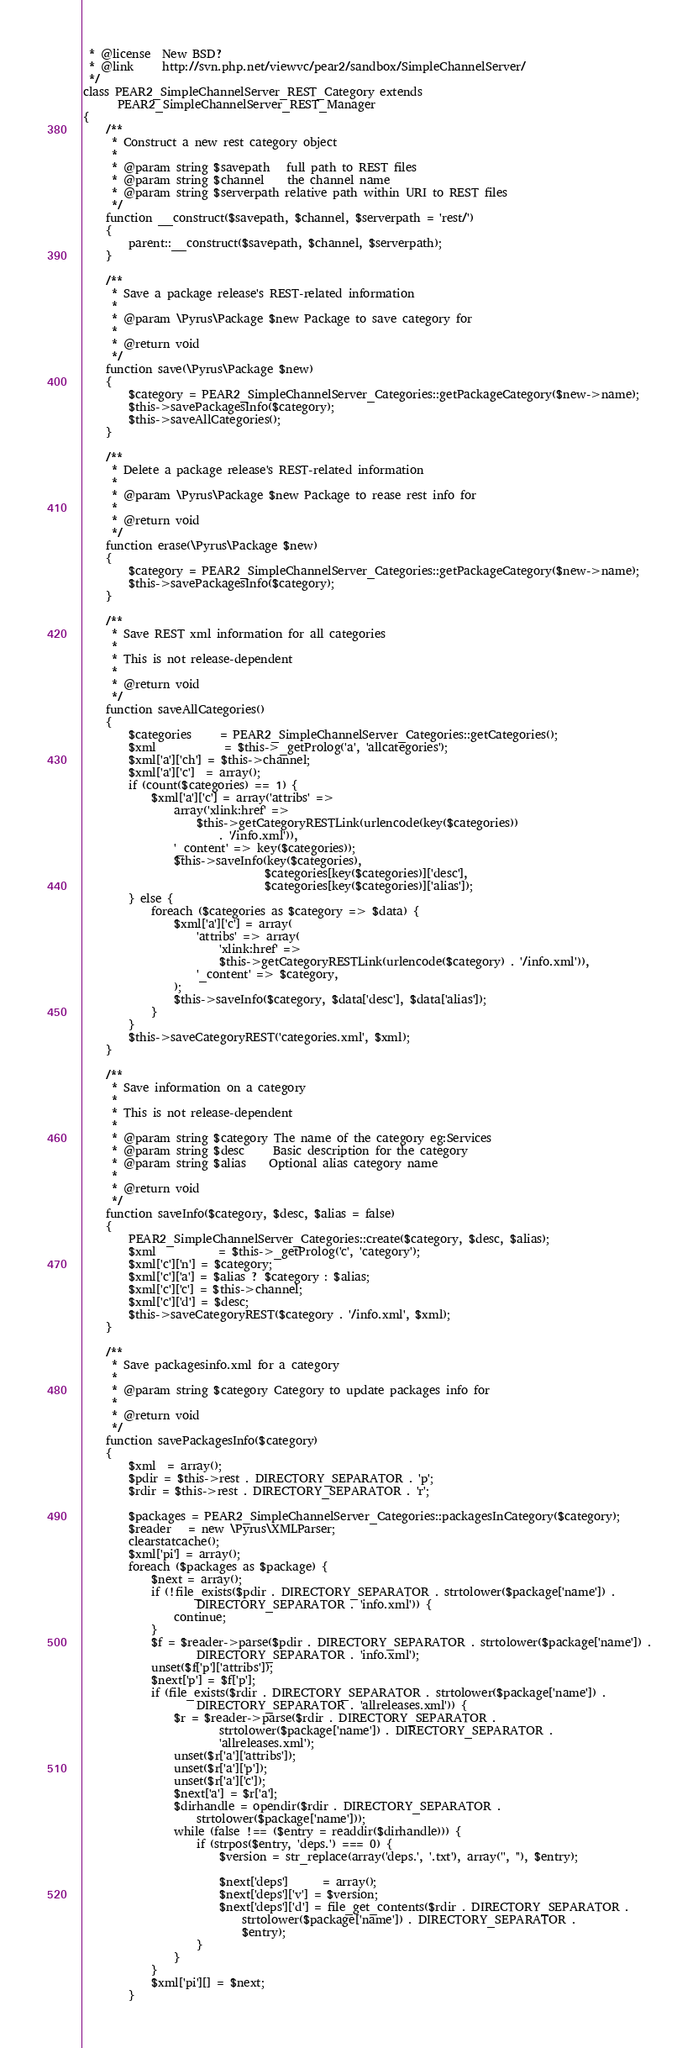<code> <loc_0><loc_0><loc_500><loc_500><_PHP_> * @license  New BSD?
 * @link     http://svn.php.net/viewvc/pear2/sandbox/SimpleChannelServer/
 */
class PEAR2_SimpleChannelServer_REST_Category extends
      PEAR2_SimpleChannelServer_REST_Manager
{
    /**
     * Construct a new rest category object
     * 
     * @param string $savepath   full path to REST files
     * @param string $channel    the channel name
     * @param string $serverpath relative path within URI to REST files
     */
    function __construct($savepath, $channel, $serverpath = 'rest/')
    {
        parent::__construct($savepath, $channel, $serverpath);
    }

    /**
     * Save a package release's REST-related information
     *
     * @param \Pyrus\Package $new Package to save category for
     * 
     * @return void
     */
    function save(\Pyrus\Package $new)
    {
        $category = PEAR2_SimpleChannelServer_Categories::getPackageCategory($new->name);
        $this->savePackagesInfo($category);
        $this->saveAllCategories();
    }

    /**
     * Delete a package release's REST-related information
     *
     * @param \Pyrus\Package $new Package to rease rest info for
     * 
     * @return void
     */
    function erase(\Pyrus\Package $new)
    {
        $category = PEAR2_SimpleChannelServer_Categories::getPackageCategory($new->name);
        $this->savePackagesInfo($category);
    }

    /**
     * Save REST xml information for all categories
     * 
     * This is not release-dependent
     * 
     * @return void
     */
    function saveAllCategories()
    {
        $categories     = PEAR2_SimpleChannelServer_Categories::getCategories();
        $xml            = $this->_getProlog('a', 'allcategories');
        $xml['a']['ch'] = $this->channel;
        $xml['a']['c']  = array();
        if (count($categories) == 1) {
            $xml['a']['c'] = array('attribs' =>
                array('xlink:href' =>
                    $this->getCategoryRESTLink(urlencode(key($categories))
                        . '/info.xml')),
                '_content' => key($categories));
                $this->saveInfo(key($categories),
                                $categories[key($categories)]['desc'],
                                $categories[key($categories)]['alias']);
        } else {
            foreach ($categories as $category => $data) {
                $xml['a']['c'] = array(
                    'attribs' => array(
                        'xlink:href' =>
                        $this->getCategoryRESTLink(urlencode($category) . '/info.xml')),
                    '_content' => $category,
                );
                $this->saveInfo($category, $data['desc'], $data['alias']);
            }
        }
        $this->saveCategoryREST('categories.xml', $xml);
    }

    /**
     * Save information on a category
     * 
     * This is not release-dependent
     *
     * @param string $category The name of the category eg:Services
     * @param string $desc     Basic description for the category
     * @param string $alias    Optional alias category name
     * 
     * @return void
     */
    function saveInfo($category, $desc, $alias = false)
    {
        PEAR2_SimpleChannelServer_Categories::create($category, $desc, $alias);
        $xml           = $this->_getProlog('c', 'category');
        $xml['c']['n'] = $category;
        $xml['c']['a'] = $alias ? $category : $alias;
        $xml['c']['c'] = $this->channel;
        $xml['c']['d'] = $desc;
        $this->saveCategoryREST($category . '/info.xml', $xml);
    }

    /**
     * Save packagesinfo.xml for a category
     *
     * @param string $category Category to update packages info for
     * 
     * @return void
     */
    function savePackagesInfo($category)
    {
        $xml  = array();
        $pdir = $this->rest . DIRECTORY_SEPARATOR . 'p';
        $rdir = $this->rest . DIRECTORY_SEPARATOR . 'r';

        $packages = PEAR2_SimpleChannelServer_Categories::packagesInCategory($category);
        $reader   = new \Pyrus\XMLParser;
        clearstatcache();
        $xml['pi'] = array();
        foreach ($packages as $package) {
            $next = array();
            if (!file_exists($pdir . DIRECTORY_SEPARATOR . strtolower($package['name']) .
                    DIRECTORY_SEPARATOR . 'info.xml')) {
                continue;
            }
            $f = $reader->parse($pdir . DIRECTORY_SEPARATOR . strtolower($package['name']) .
                    DIRECTORY_SEPARATOR . 'info.xml');
            unset($f['p']['attribs']);
            $next['p'] = $f['p'];
            if (file_exists($rdir . DIRECTORY_SEPARATOR . strtolower($package['name']) .
                    DIRECTORY_SEPARATOR . 'allreleases.xml')) {
                $r = $reader->parse($rdir . DIRECTORY_SEPARATOR .
                        strtolower($package['name']) . DIRECTORY_SEPARATOR .
                        'allreleases.xml');
                unset($r['a']['attribs']);
                unset($r['a']['p']);
                unset($r['a']['c']);
                $next['a'] = $r['a'];
                $dirhandle = opendir($rdir . DIRECTORY_SEPARATOR .
                    strtolower($package['name']));
                while (false !== ($entry = readdir($dirhandle))) {
                    if (strpos($entry, 'deps.') === 0) {
                        $version = str_replace(array('deps.', '.txt'), array('', ''), $entry);
                        
                        $next['deps']      = array();
                        $next['deps']['v'] = $version;
                        $next['deps']['d'] = file_get_contents($rdir . DIRECTORY_SEPARATOR .
                            strtolower($package['name']) . DIRECTORY_SEPARATOR .
                            $entry);
                    }
                }
            }
            $xml['pi'][] = $next;
        }</code> 